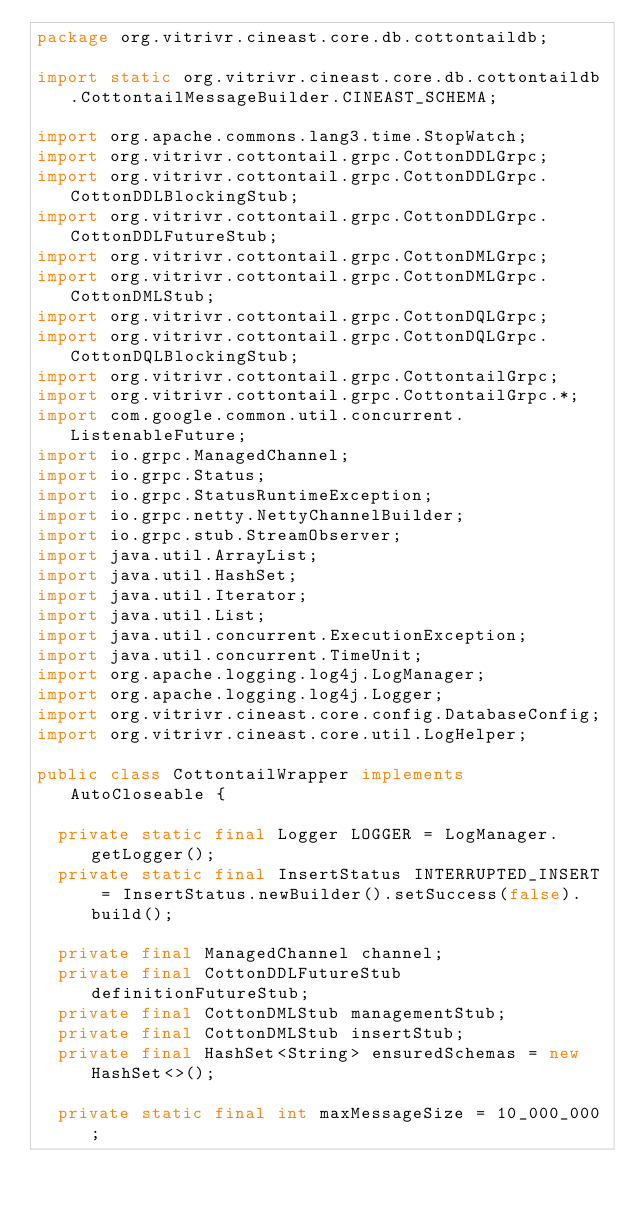Convert code to text. <code><loc_0><loc_0><loc_500><loc_500><_Java_>package org.vitrivr.cineast.core.db.cottontaildb;

import static org.vitrivr.cineast.core.db.cottontaildb.CottontailMessageBuilder.CINEAST_SCHEMA;

import org.apache.commons.lang3.time.StopWatch;
import org.vitrivr.cottontail.grpc.CottonDDLGrpc;
import org.vitrivr.cottontail.grpc.CottonDDLGrpc.CottonDDLBlockingStub;
import org.vitrivr.cottontail.grpc.CottonDDLGrpc.CottonDDLFutureStub;
import org.vitrivr.cottontail.grpc.CottonDMLGrpc;
import org.vitrivr.cottontail.grpc.CottonDMLGrpc.CottonDMLStub;
import org.vitrivr.cottontail.grpc.CottonDQLGrpc;
import org.vitrivr.cottontail.grpc.CottonDQLGrpc.CottonDQLBlockingStub;
import org.vitrivr.cottontail.grpc.CottontailGrpc;
import org.vitrivr.cottontail.grpc.CottontailGrpc.*;
import com.google.common.util.concurrent.ListenableFuture;
import io.grpc.ManagedChannel;
import io.grpc.Status;
import io.grpc.StatusRuntimeException;
import io.grpc.netty.NettyChannelBuilder;
import io.grpc.stub.StreamObserver;
import java.util.ArrayList;
import java.util.HashSet;
import java.util.Iterator;
import java.util.List;
import java.util.concurrent.ExecutionException;
import java.util.concurrent.TimeUnit;
import org.apache.logging.log4j.LogManager;
import org.apache.logging.log4j.Logger;
import org.vitrivr.cineast.core.config.DatabaseConfig;
import org.vitrivr.cineast.core.util.LogHelper;

public class CottontailWrapper implements AutoCloseable {

  private static final Logger LOGGER = LogManager.getLogger();
  private static final InsertStatus INTERRUPTED_INSERT = InsertStatus.newBuilder().setSuccess(false).build();

  private final ManagedChannel channel;
  private final CottonDDLFutureStub definitionFutureStub;
  private final CottonDMLStub managementStub;
  private final CottonDMLStub insertStub;
  private final HashSet<String> ensuredSchemas = new HashSet<>();

  private static final int maxMessageSize = 10_000_000;</code> 